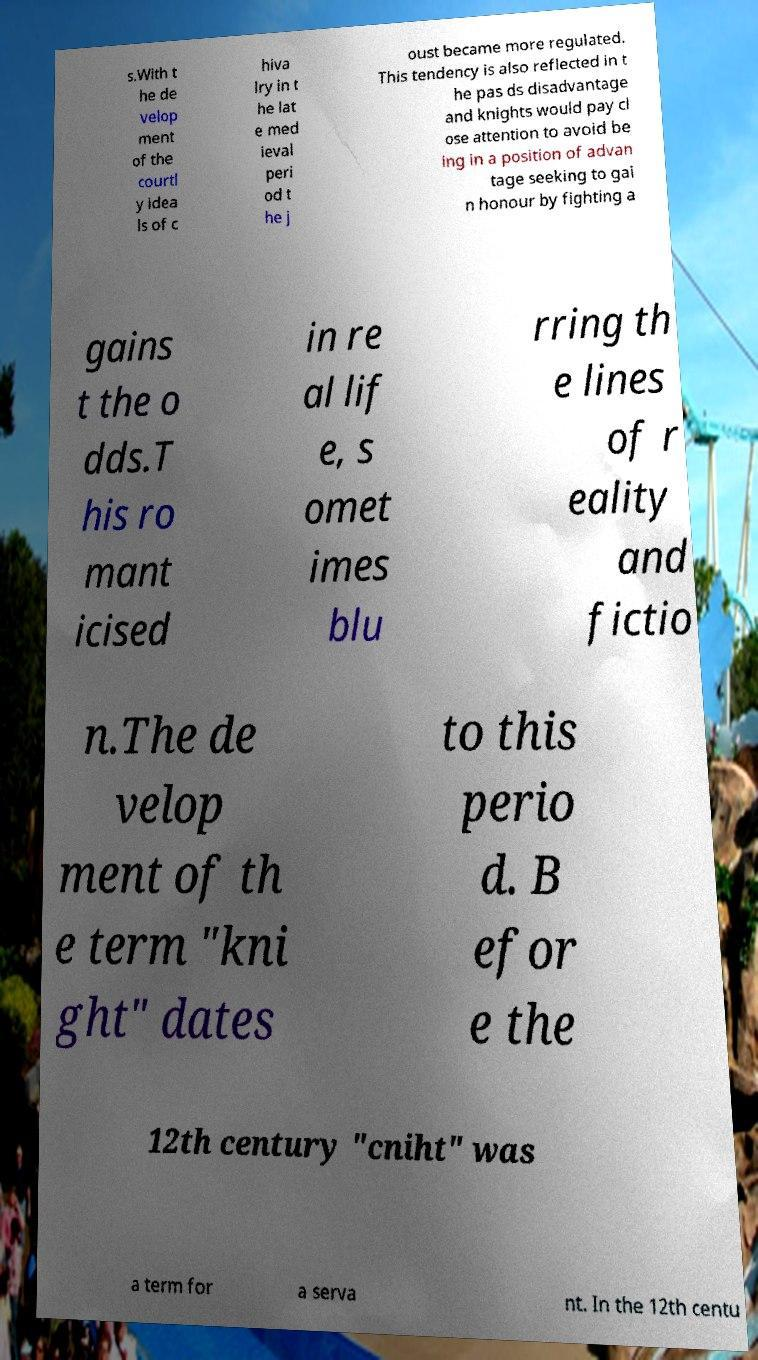What messages or text are displayed in this image? I need them in a readable, typed format. s.With t he de velop ment of the courtl y idea ls of c hiva lry in t he lat e med ieval peri od t he j oust became more regulated. This tendency is also reflected in t he pas ds disadvantage and knights would pay cl ose attention to avoid be ing in a position of advan tage seeking to gai n honour by fighting a gains t the o dds.T his ro mant icised in re al lif e, s omet imes blu rring th e lines of r eality and fictio n.The de velop ment of th e term "kni ght" dates to this perio d. B efor e the 12th century "cniht" was a term for a serva nt. In the 12th centu 